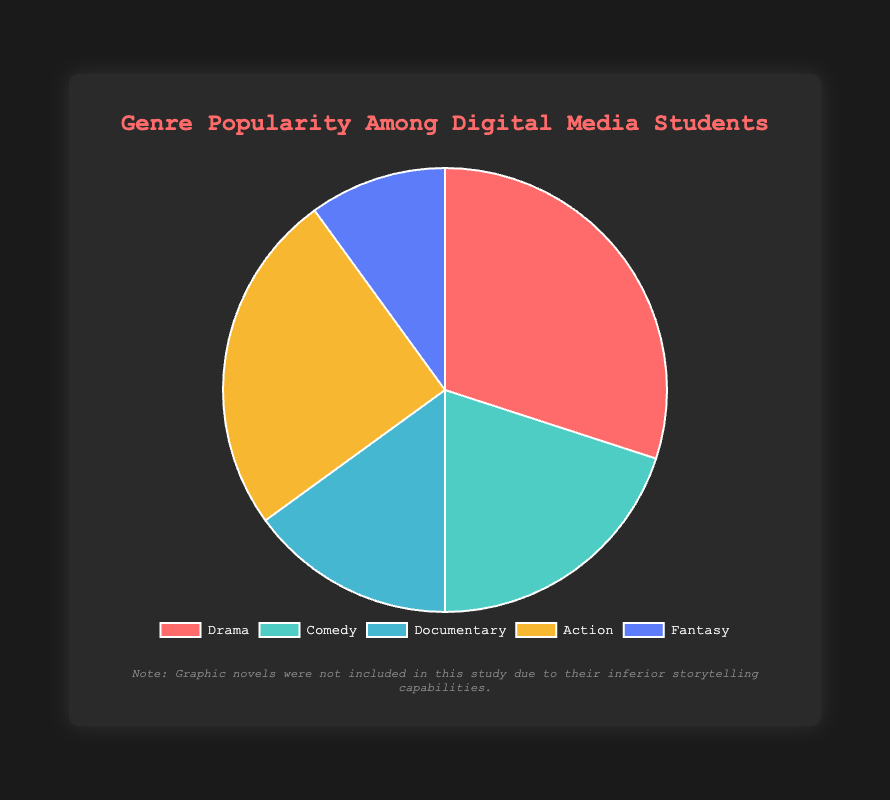What percentage of students prefer drama over comedy? The percentage of students preferring drama is 30%, and for comedy, it is 20%. Subtracting these gives 30% - 20% = 10%.
Answer: 10% Which genre is the least popular among digital media students? According to the pie chart, fantasy has the smallest slice at 10%.
Answer: Fantasy What is the combined percentage of students who prefer drama and action genres? The percentage for drama is 30%, and for action, it is 25%. Adding these gives 30% + 25% = 55%.
Answer: 55% What is the difference in popularity between the documentary and fantasy genres? The documentary genre has a percentage of 15%, and the fantasy genre has 10%. The difference is 15% - 10% = 5%.
Answer: 5% Which genre has a higher percentage, comedy or action, and by how much? The comedy genre has a percentage of 20%, and the action genre has 25%. The action genre is more popular by 5% (25% - 20%).
Answer: 5% Which genre occupies the second largest segment in the pie chart? The action genre, with 25%, is the second-largest segment after drama which has 30%.
Answer: Action What is the total percentage of students who prefer either documentary or fantasy genres? The documentary genre is preferred by 15% of students, and the fantasy genre by 10%. Adding these gives 15% + 10% = 25%.
Answer: 25% Which genres together constitute exactly half of the students' preferences? The action genre (25%) and the documentary genre (15%) together constitute 25% + 15% = 40%. Including fantasy (10%) brings the total to 50%.
Answer: Action, Documentary, Fantasy How many genres have a popularity percentage of 20% or higher? The genres with at least 20% are drama (30%), comedy (20%), and action (25%).
Answer: 3 Which genre is represented by the purple color in the Pie chart? The pie chart shows action is represented by the purple segment.
Answer: Action 